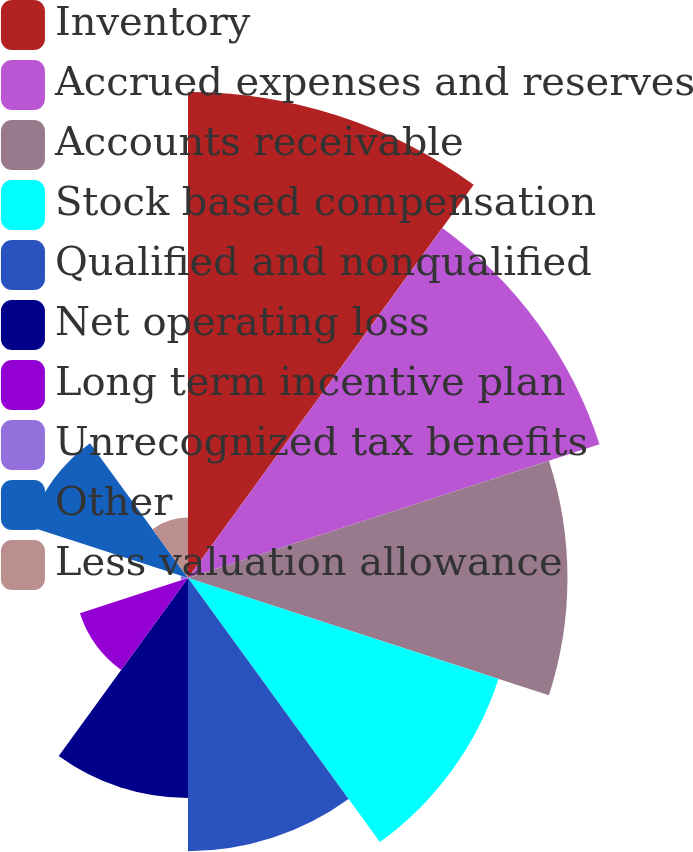<chart> <loc_0><loc_0><loc_500><loc_500><pie_chart><fcel>Inventory<fcel>Accrued expenses and reserves<fcel>Accounts receivable<fcel>Stock based compensation<fcel>Qualified and nonqualified<fcel>Net operating loss<fcel>Long term incentive plan<fcel>Unrecognized tax benefits<fcel>Other<fcel>Less valuation allowance<nl><fcel>19.71%<fcel>17.55%<fcel>15.39%<fcel>13.24%<fcel>11.08%<fcel>8.92%<fcel>4.61%<fcel>0.29%<fcel>6.76%<fcel>2.45%<nl></chart> 